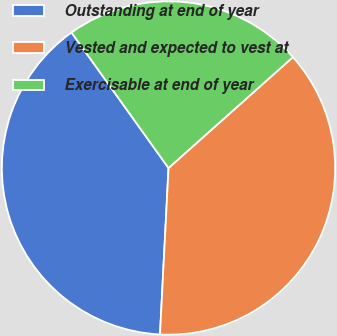Convert chart. <chart><loc_0><loc_0><loc_500><loc_500><pie_chart><fcel>Outstanding at end of year<fcel>Vested and expected to vest at<fcel>Exercisable at end of year<nl><fcel>39.3%<fcel>37.41%<fcel>23.3%<nl></chart> 